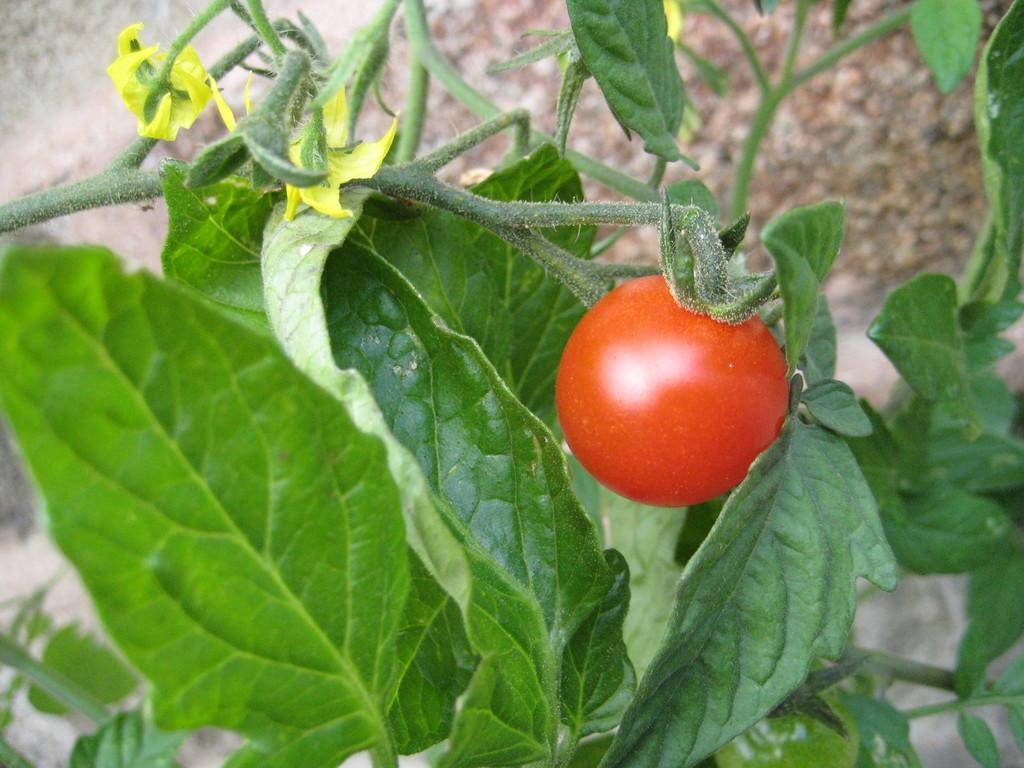What type of plant is in the image? There is a tomato plant in the image. Where is the tomato plant located? The tomato plant is on a surface. What additional features can be seen on the tomato plant? There are flowers on the tomato plant. How does the tomato plant use a comb in the image? There is no comb present in the image, so the tomato plant cannot use one. 